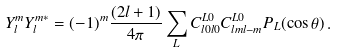Convert formula to latex. <formula><loc_0><loc_0><loc_500><loc_500>Y _ { l } ^ { m } Y _ { l } ^ { m * } = ( - 1 ) ^ { m } \frac { ( 2 l + 1 ) } { 4 \pi } \sum _ { L } C ^ { L 0 } _ { l 0 l 0 } C ^ { L 0 } _ { l m l - m } P _ { L } ( \cos \theta ) \, .</formula> 